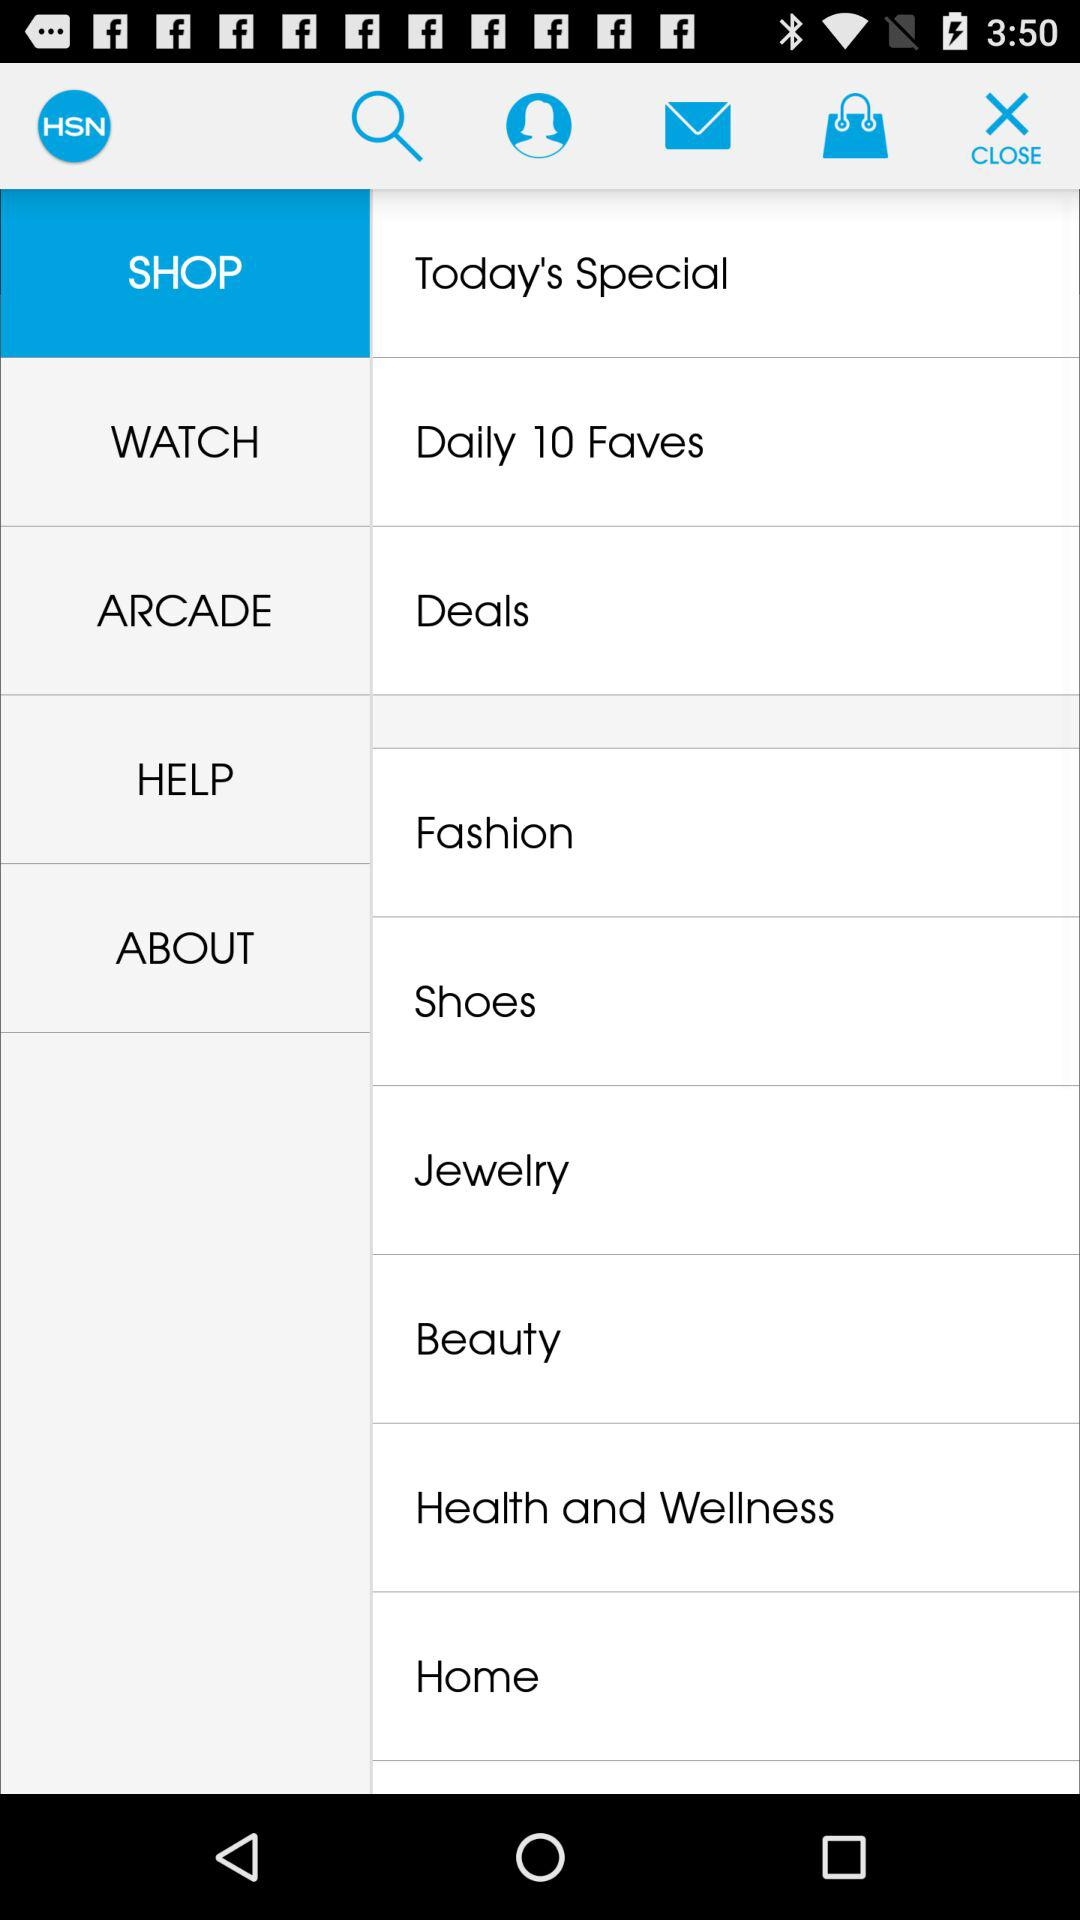What is the website address?
When the provided information is insufficient, respond with <no answer>. <no answer> 